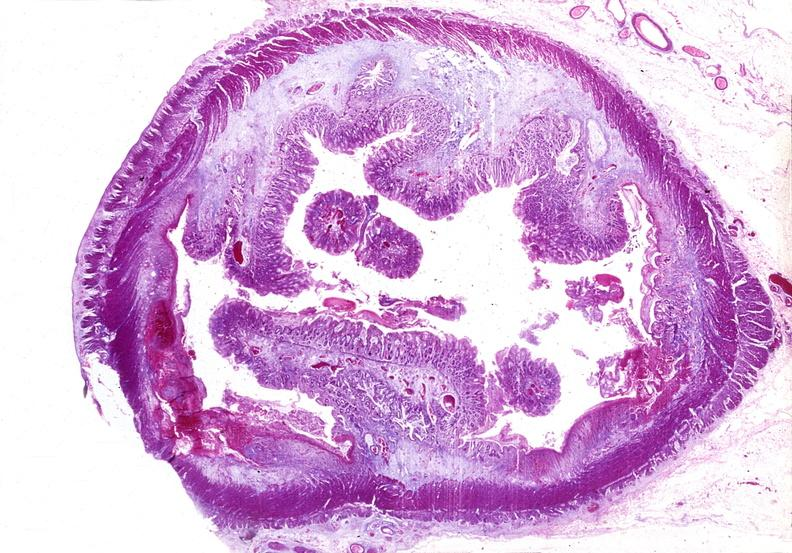s gastrointestinal present?
Answer the question using a single word or phrase. Yes 